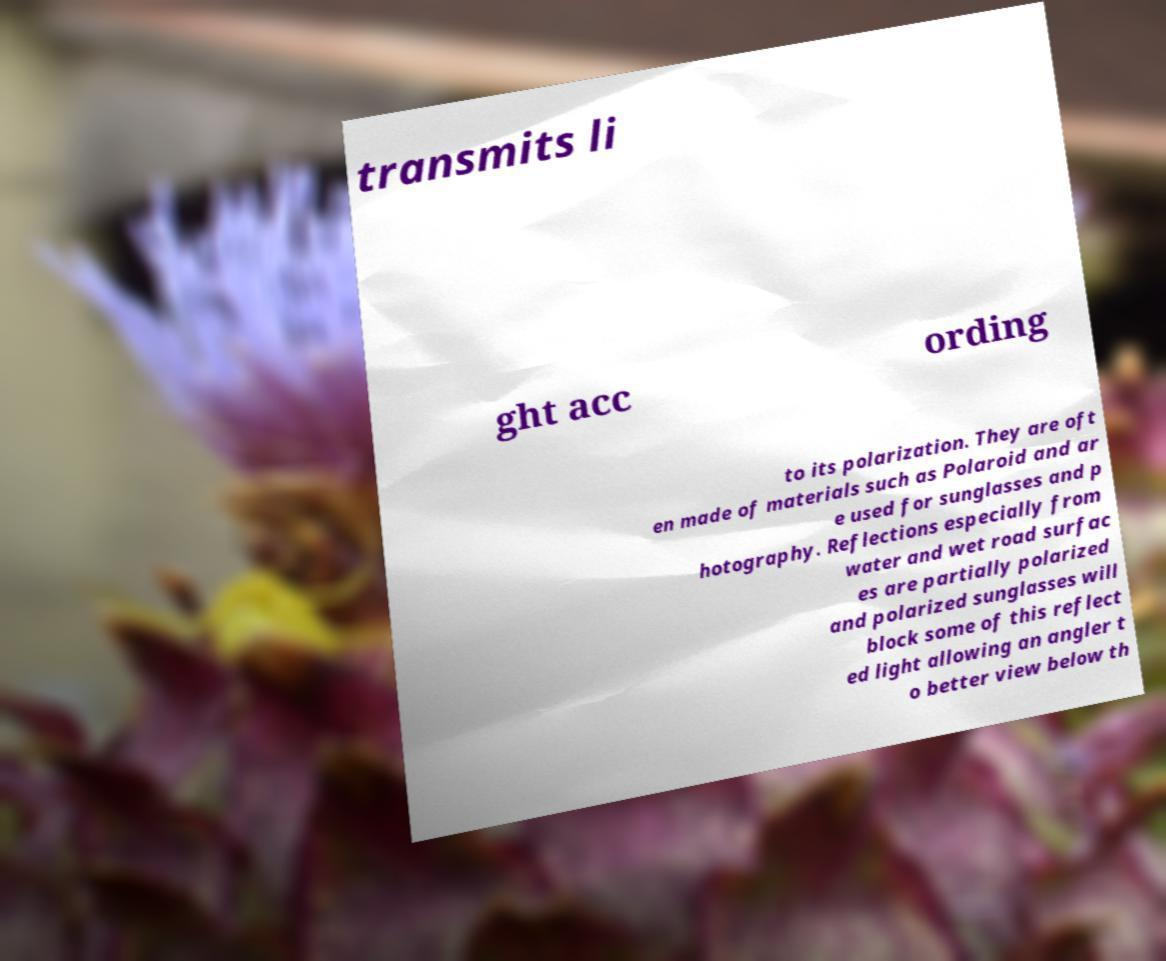I need the written content from this picture converted into text. Can you do that? transmits li ght acc ording to its polarization. They are oft en made of materials such as Polaroid and ar e used for sunglasses and p hotography. Reflections especially from water and wet road surfac es are partially polarized and polarized sunglasses will block some of this reflect ed light allowing an angler t o better view below th 